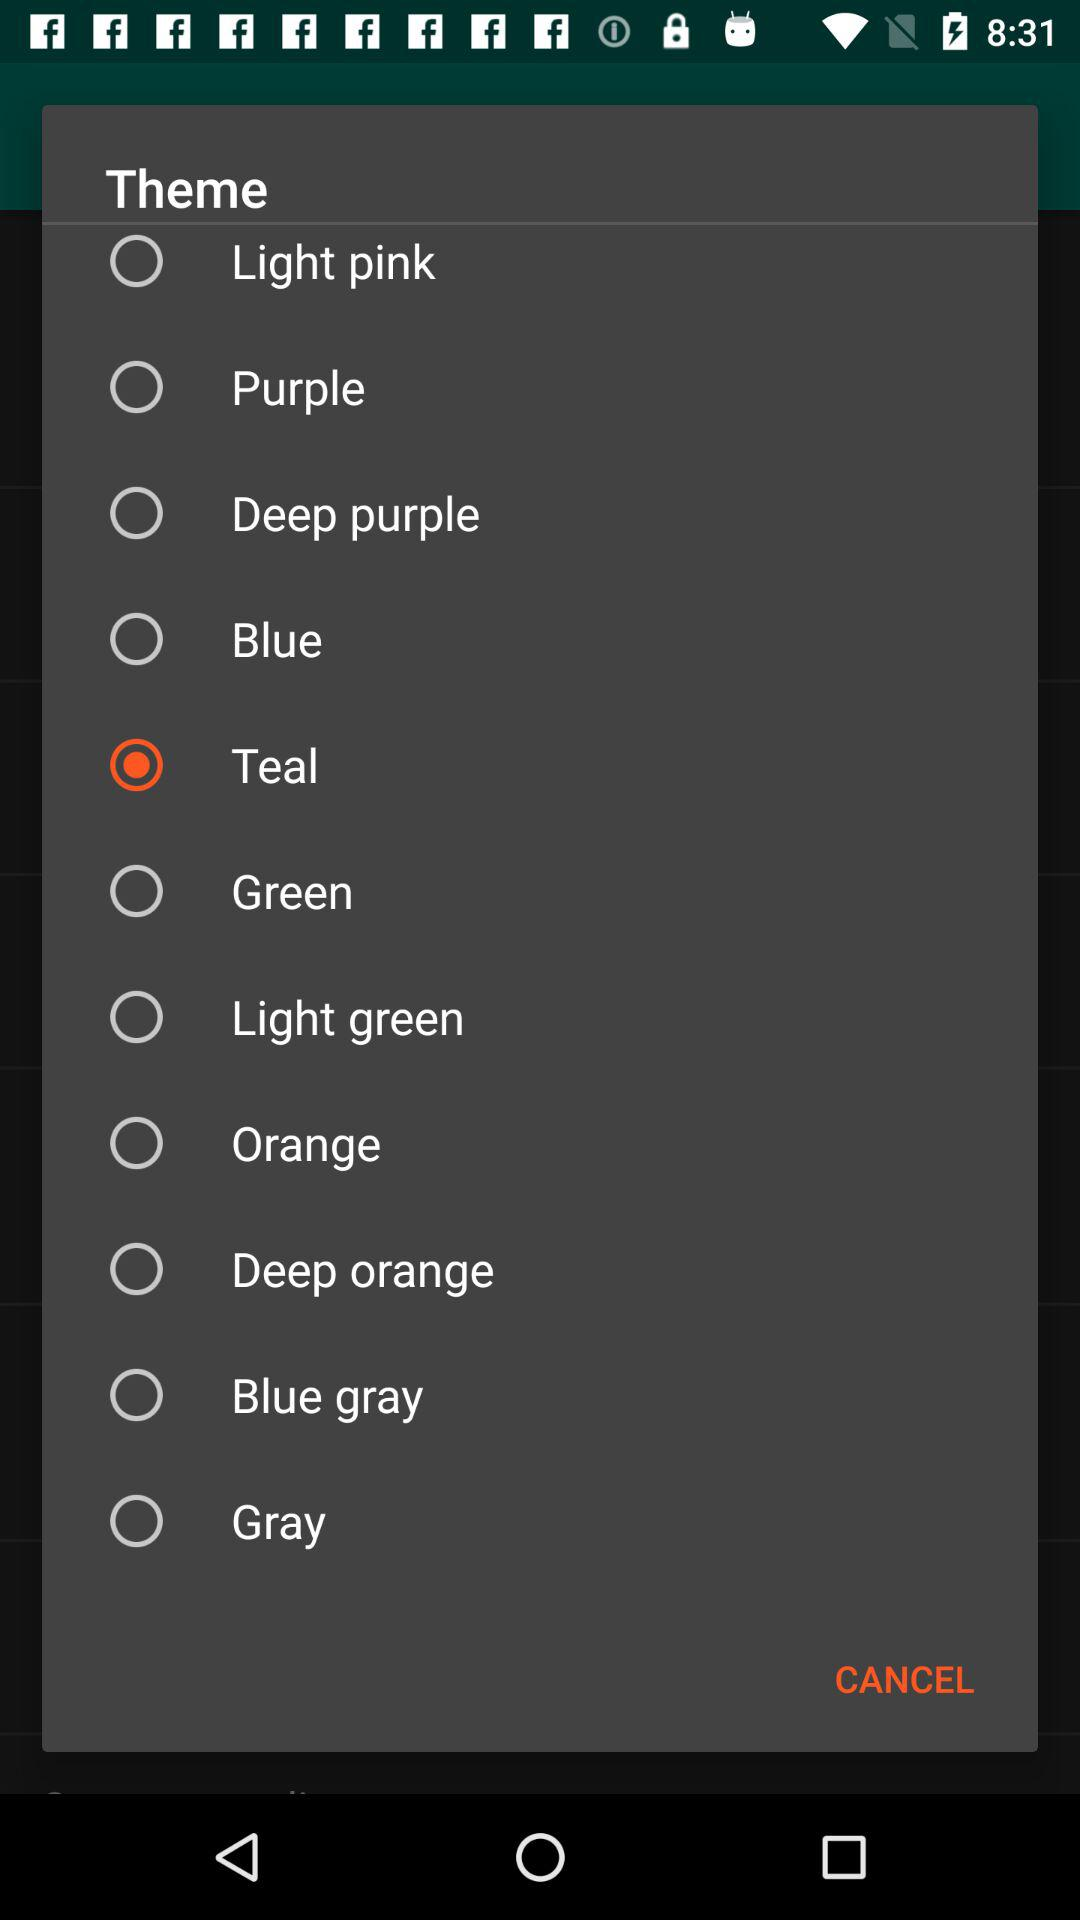Which is the selected option? The selected option is "Teal". 